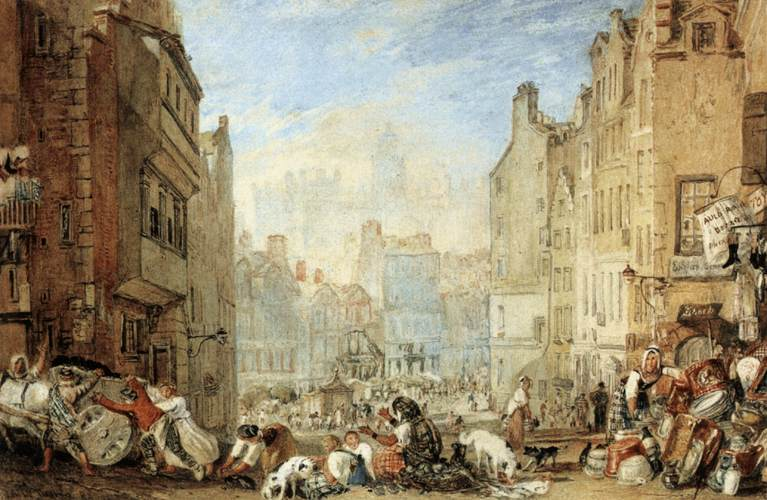Describe the following image. The image presents a lively street scene from what could be an 18th or 19th-century European town. In the foreground, we observe a bustling market, with vendors selling goods and people milling about, some seated while others interact or go about their business. The buildings, while grand, show signs of wear, implying a well-established city with a rich history. The art style, which seems to capture life with a sense of immediacy and the candid expressions of the figures, suggests the painting might be of the Romantic period, emphasizing the realistic depiction of everyday scenes. Additionally, the sky, washed in shades of blue and white, hints at the vastness above the crowded urban life, giving the scene a breathable space. 